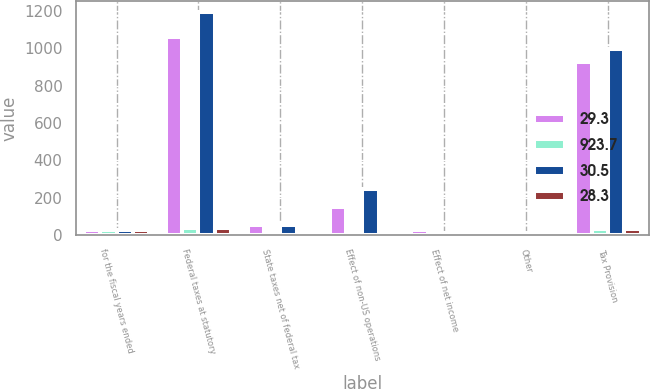<chart> <loc_0><loc_0><loc_500><loc_500><stacked_bar_chart><ecel><fcel>for the fiscal years ended<fcel>Federal taxes at statutory<fcel>State taxes net of federal tax<fcel>Effect of non-US operations<fcel>Effect of net income<fcel>Other<fcel>Tax Provision<nl><fcel>29.3<fcel>26.8<fcel>1059.9<fcel>51.6<fcel>148.5<fcel>24.3<fcel>15<fcel>923.7<nl><fcel>923.7<fcel>26.8<fcel>35<fcel>1.7<fcel>4.9<fcel>0.8<fcel>0.5<fcel>30.5<nl><fcel>30.5<fcel>26.8<fcel>1193.4<fcel>52.4<fcel>246.3<fcel>9.6<fcel>8<fcel>997.9<nl><fcel>28.3<fcel>26.8<fcel>35<fcel>1.5<fcel>7.2<fcel>0.3<fcel>0.3<fcel>29.3<nl></chart> 